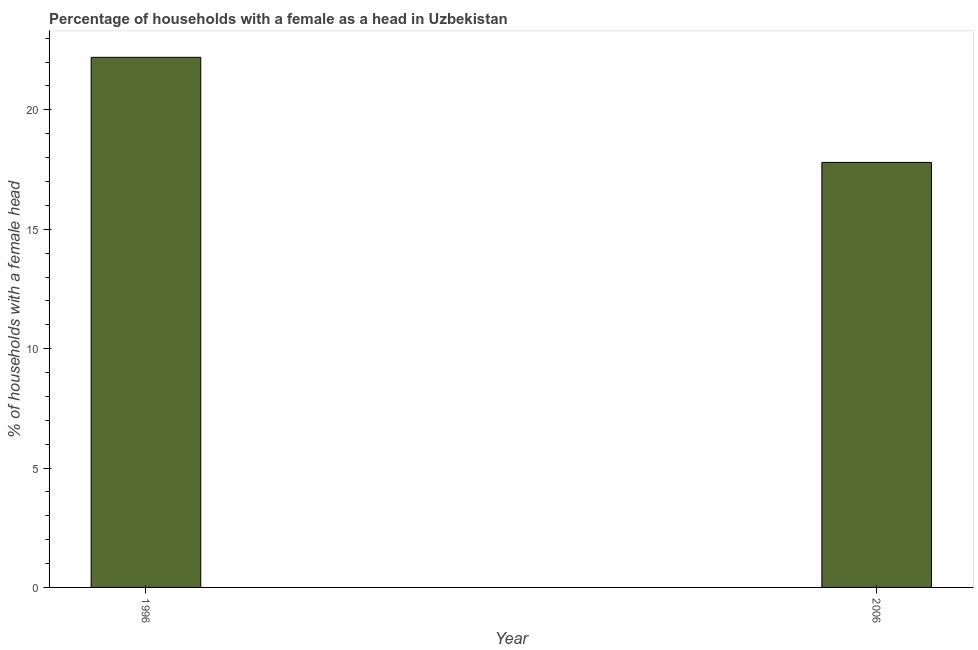What is the title of the graph?
Offer a very short reply. Percentage of households with a female as a head in Uzbekistan. What is the label or title of the Y-axis?
Provide a short and direct response. % of households with a female head. What is the number of female supervised households in 2006?
Give a very brief answer. 17.8. Across all years, what is the maximum number of female supervised households?
Your response must be concise. 22.2. What is the average number of female supervised households per year?
Provide a short and direct response. 20. What is the median number of female supervised households?
Ensure brevity in your answer.  20. Do a majority of the years between 2006 and 1996 (inclusive) have number of female supervised households greater than 5 %?
Provide a short and direct response. No. What is the ratio of the number of female supervised households in 1996 to that in 2006?
Your response must be concise. 1.25. In how many years, is the number of female supervised households greater than the average number of female supervised households taken over all years?
Your response must be concise. 1. How many bars are there?
Offer a terse response. 2. Are all the bars in the graph horizontal?
Provide a succinct answer. No. How many years are there in the graph?
Offer a very short reply. 2. Are the values on the major ticks of Y-axis written in scientific E-notation?
Provide a short and direct response. No. What is the % of households with a female head in 2006?
Provide a short and direct response. 17.8. What is the ratio of the % of households with a female head in 1996 to that in 2006?
Make the answer very short. 1.25. 